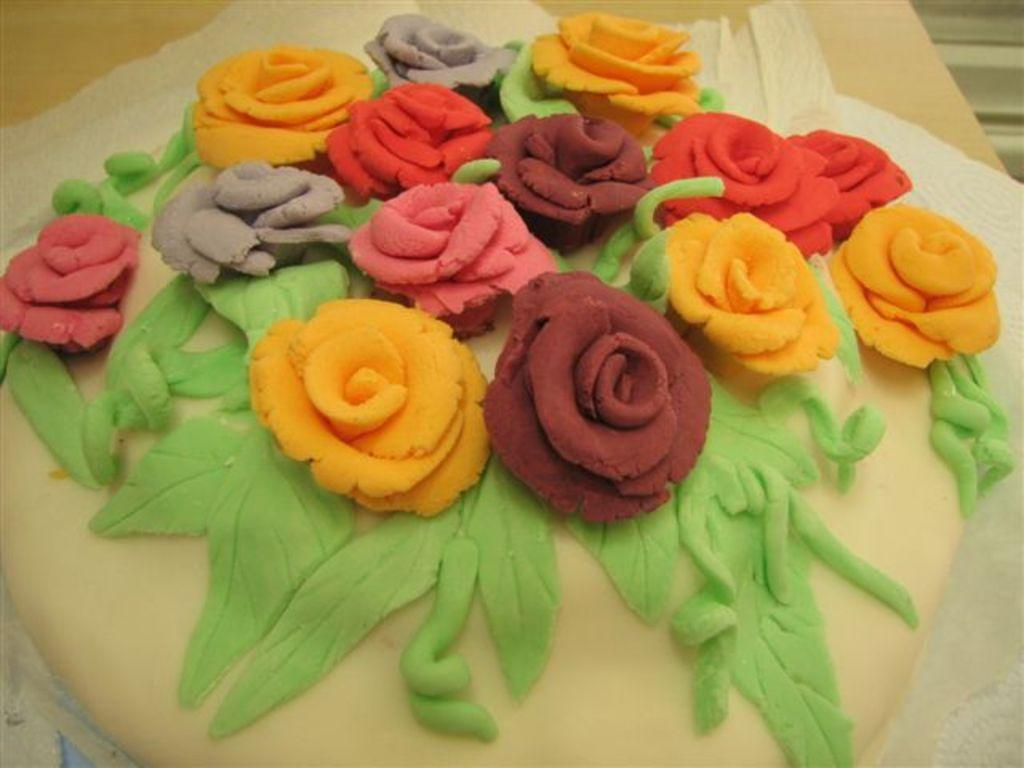What is the main subject of the image? There is a cake in the image. What else can be seen in the image besides the cake? There are tissues in the image. Where are the cake and tissues located? The cake and tissues are on a wooden board. What type of experience does the toad have with the cake in the image? There is no toad present in the image, so it cannot be determined if the toad has any experience with the cake. 